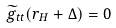Convert formula to latex. <formula><loc_0><loc_0><loc_500><loc_500>\widetilde { g } _ { t t } ( r _ { H } + \Delta ) = 0</formula> 